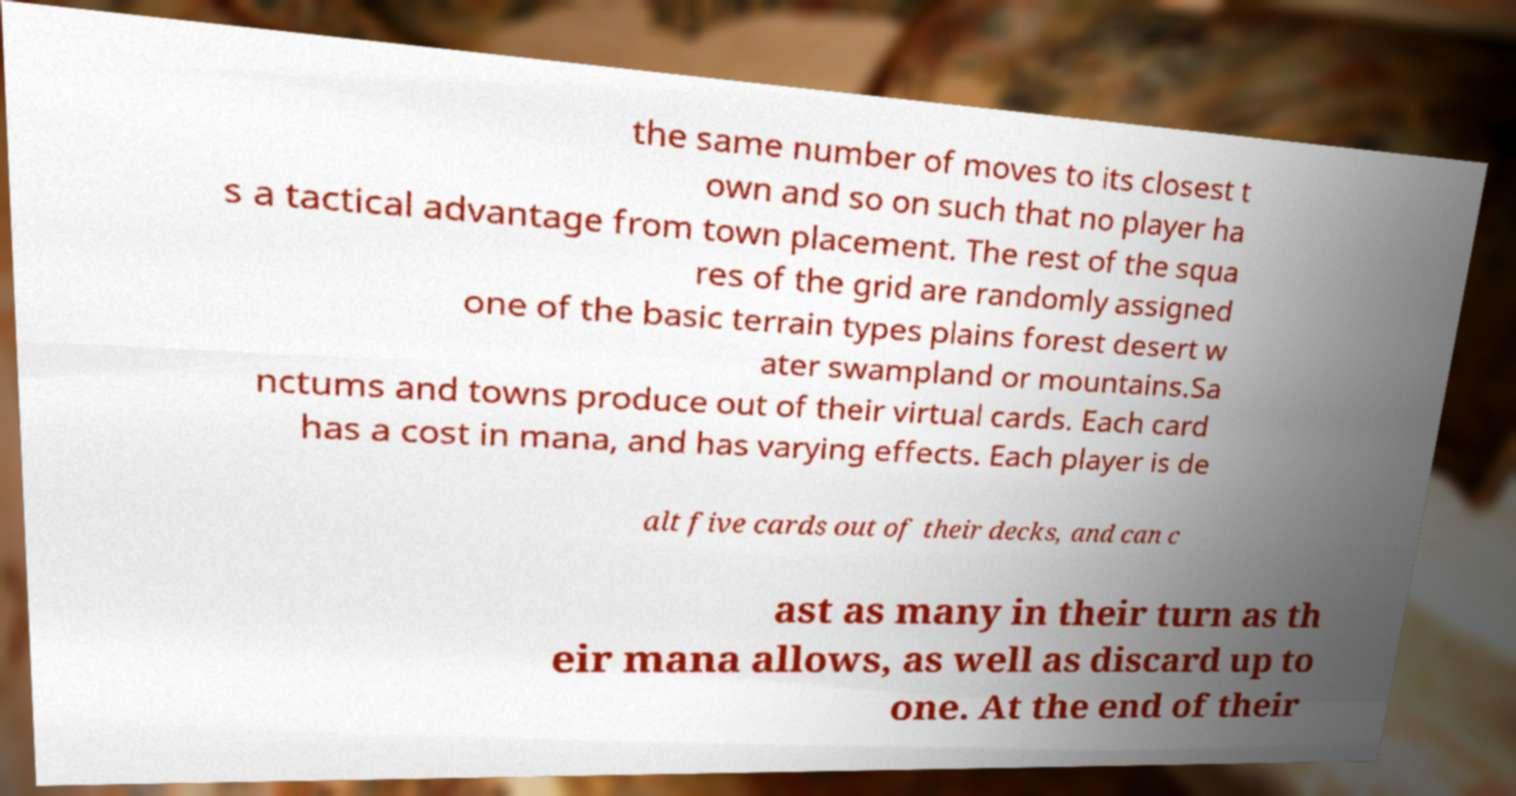What messages or text are displayed in this image? I need them in a readable, typed format. the same number of moves to its closest t own and so on such that no player ha s a tactical advantage from town placement. The rest of the squa res of the grid are randomly assigned one of the basic terrain types plains forest desert w ater swampland or mountains.Sa nctums and towns produce out of their virtual cards. Each card has a cost in mana, and has varying effects. Each player is de alt five cards out of their decks, and can c ast as many in their turn as th eir mana allows, as well as discard up to one. At the end of their 